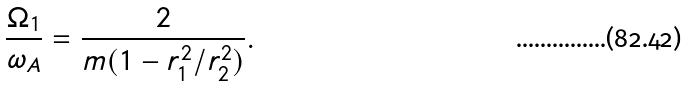<formula> <loc_0><loc_0><loc_500><loc_500>\frac { \Omega _ { 1 } } { \omega _ { A } } = \frac { 2 } { m ( 1 - r _ { 1 } ^ { 2 } / r _ { 2 } ^ { 2 } ) } .</formula> 